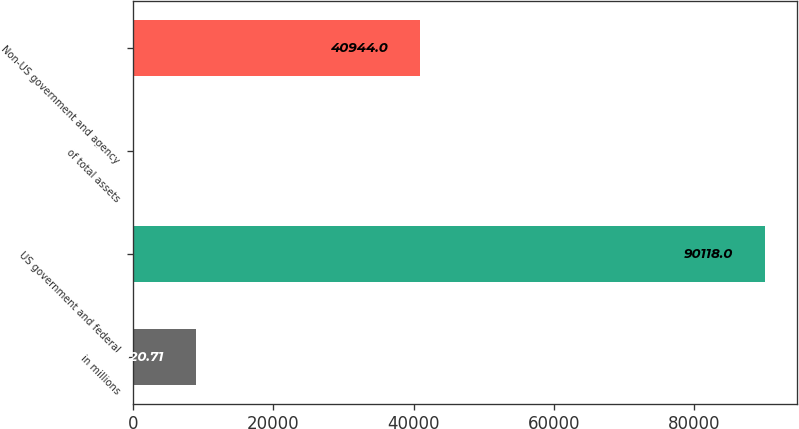Convert chart to OTSL. <chart><loc_0><loc_0><loc_500><loc_500><bar_chart><fcel>in millions<fcel>US government and federal<fcel>of total assets<fcel>Non-US government and agency<nl><fcel>9020.71<fcel>90118<fcel>9.9<fcel>40944<nl></chart> 